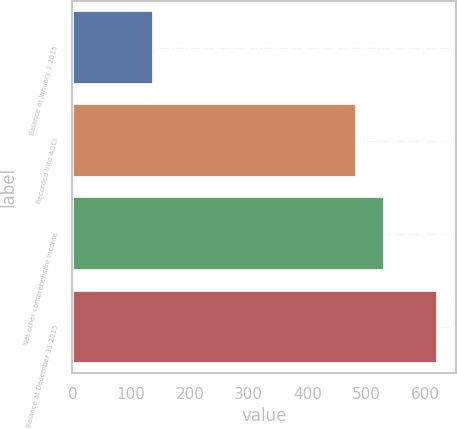<chart> <loc_0><loc_0><loc_500><loc_500><bar_chart><fcel>Balance at January 1 2015<fcel>Recorded into AOCI<fcel>Net other comprehensive income<fcel>Balance at December 31 2015<nl><fcel>138.5<fcel>483.8<fcel>532.18<fcel>622.3<nl></chart> 